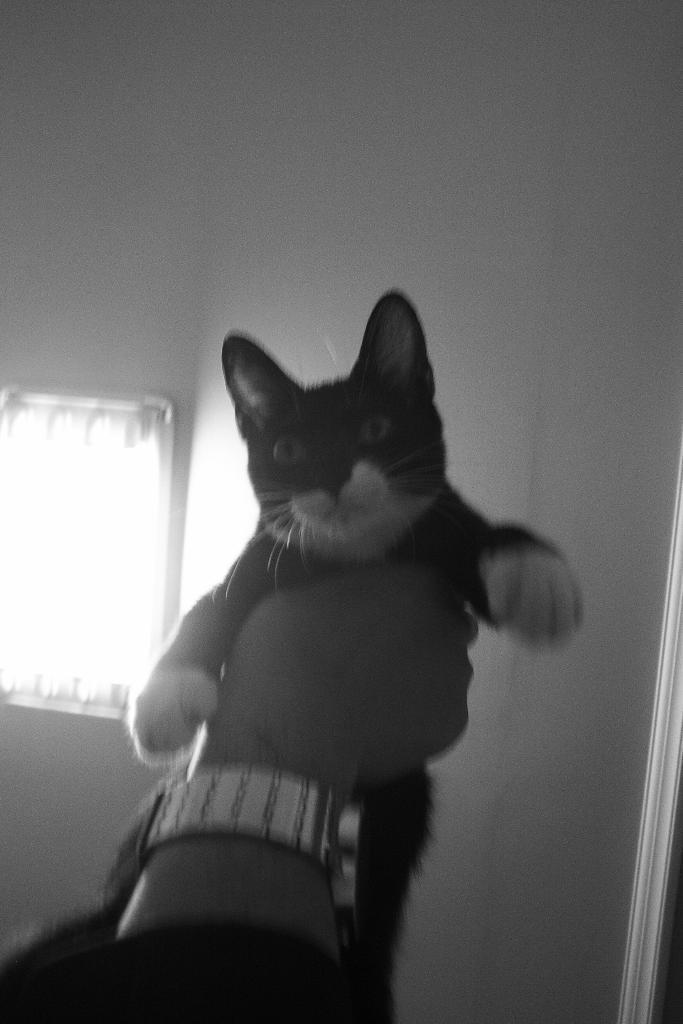What is the color scheme of the image? The image is black and white. What can be seen in the hand of the person in the image? There is a hand holding a cat in the image. What type of transport is visible in the image? There is no transport visible in the image; it features a hand holding a cat. What kind of musical instruments can be seen in the image? There are no musical instruments present in the image; it features a hand holding a cat. 